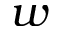<formula> <loc_0><loc_0><loc_500><loc_500>w</formula> 